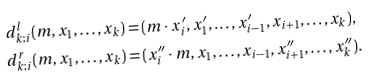<formula> <loc_0><loc_0><loc_500><loc_500>d _ { k ; i } ^ { l } & ( m , x _ { 1 } , \dots , x _ { k } ) = ( m \cdot x ^ { \prime } _ { i } , x ^ { \prime } _ { 1 } , \dots , x ^ { \prime } _ { i - 1 } , x _ { i + 1 } , \dots , x _ { k } ) , \\ d _ { k ; i } ^ { r } & ( m , x _ { 1 } , \dots , x _ { k } ) = ( x ^ { \prime \prime } _ { i } \cdot m , x _ { 1 } , \dots , x _ { i - 1 } , x ^ { \prime \prime } _ { i + 1 } , \dots , x ^ { \prime \prime } _ { k } ) .</formula> 